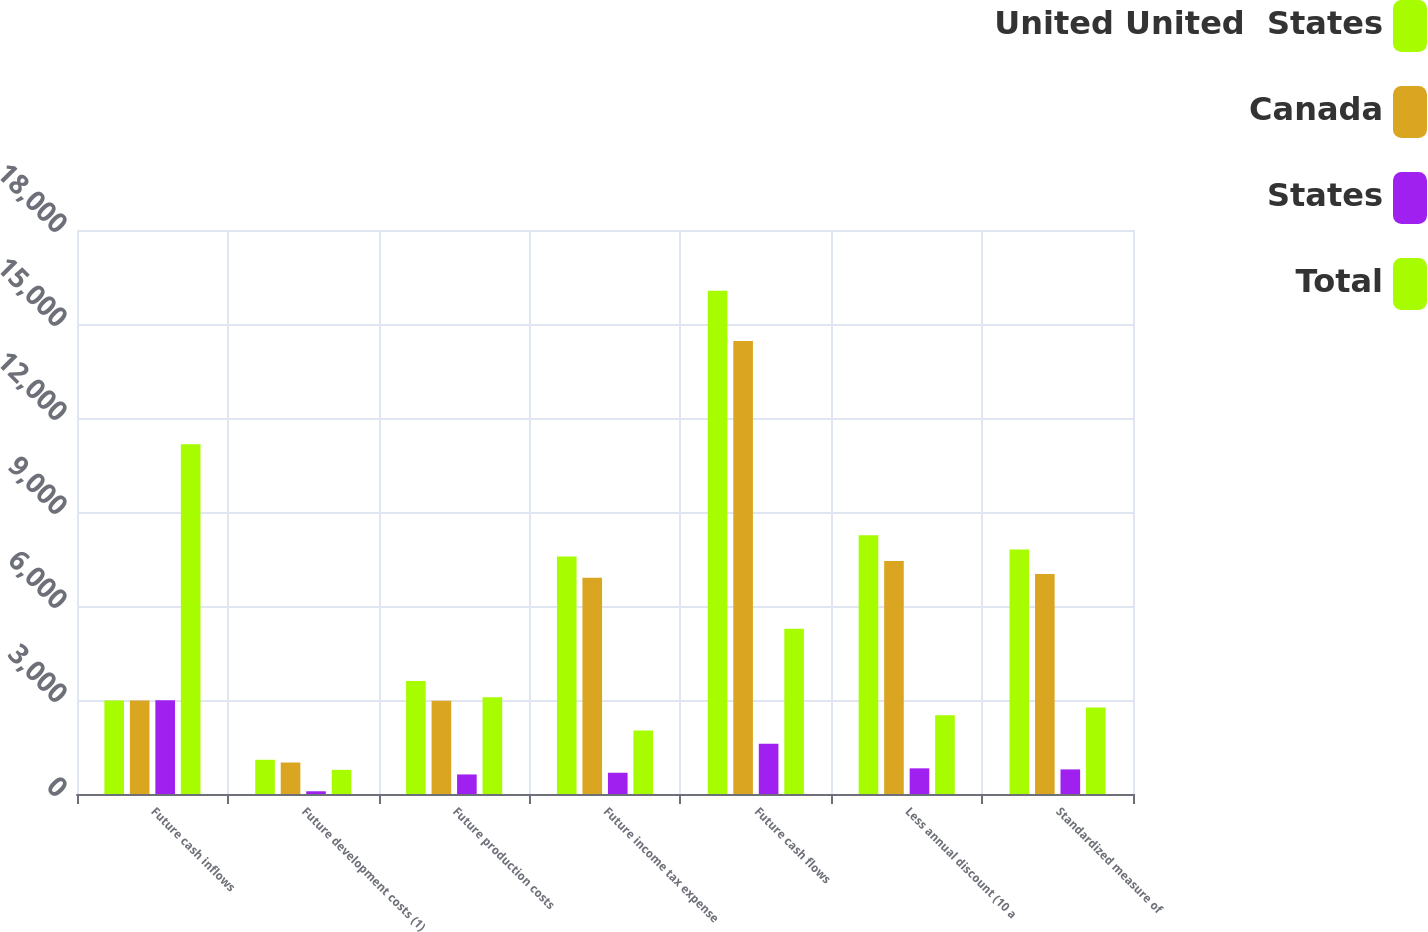Convert chart to OTSL. <chart><loc_0><loc_0><loc_500><loc_500><stacked_bar_chart><ecel><fcel>Future cash inflows<fcel>Future development costs (1)<fcel>Future production costs<fcel>Future income tax expense<fcel>Future cash flows<fcel>Less annual discount (10 a<fcel>Standardized measure of<nl><fcel>United United  States<fcel>2986<fcel>1092<fcel>3603<fcel>7582<fcel>16060<fcel>8255<fcel>7805<nl><fcel>Canada<fcel>2986<fcel>1005<fcel>2979<fcel>6904<fcel>14456<fcel>7436<fcel>7020<nl><fcel>States<fcel>2993<fcel>87<fcel>624<fcel>678<fcel>1604<fcel>819<fcel>785<nl><fcel>Total<fcel>11161<fcel>770<fcel>3091<fcel>2026<fcel>5274<fcel>2513<fcel>2761<nl></chart> 